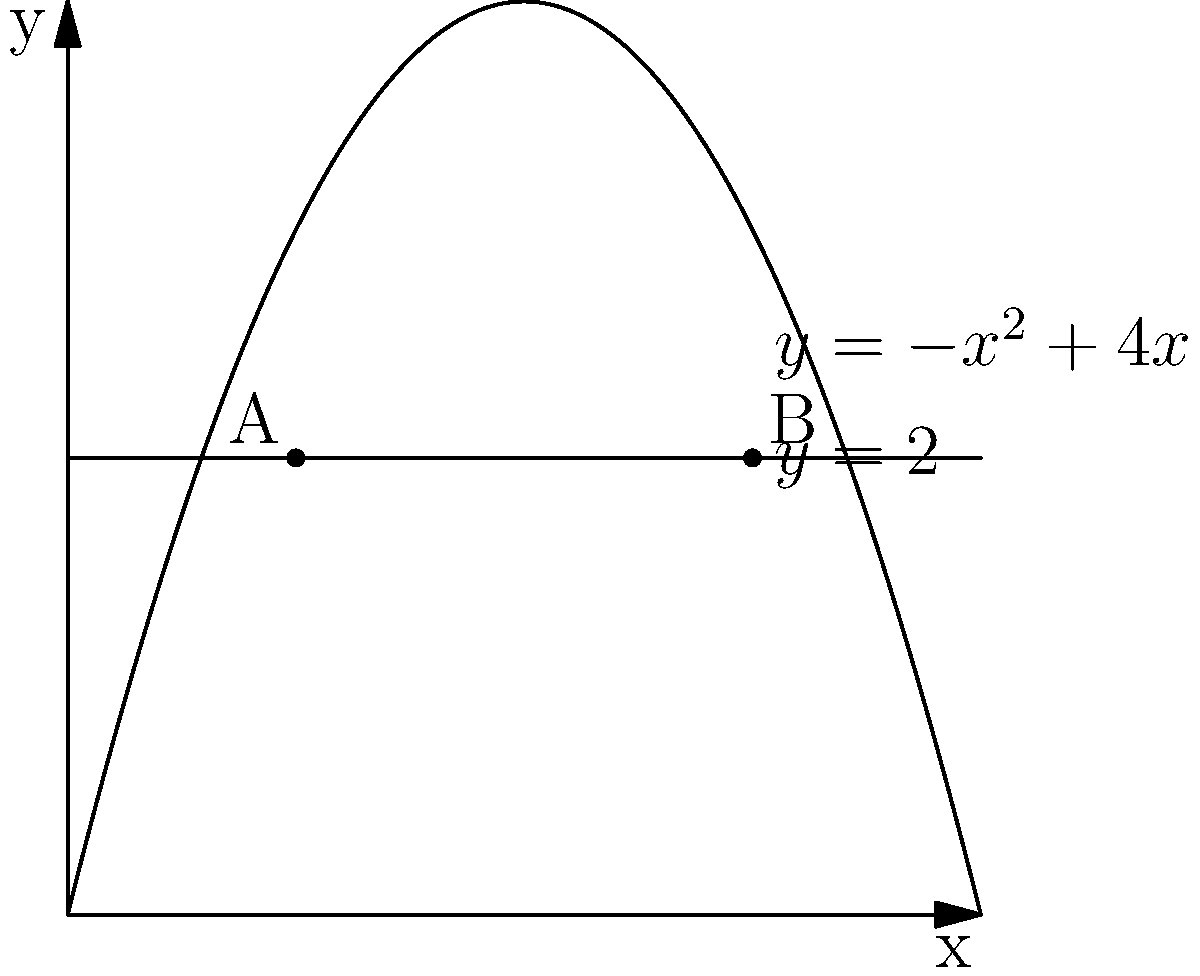A fantasy sports company wants to maximize its profit from a new mobile app. The profit function (in thousands of dollars) is given by $P(x) = -x^2 + 4x$, where $x$ represents the number of new features added to the app. However, due to budget constraints, the company can only afford to add a maximum of 2 new features. Use the method of Lagrange multipliers to determine the number of new features that should be added to maximize profit while satisfying the constraint. Let's approach this step-by-step using the method of Lagrange multipliers:

1) The objective function is $P(x) = -x^2 + 4x$
2) The constraint is $g(x) = x - 2 = 0$ (since x cannot exceed 2)

3) Form the Lagrangian function:
   $L(x,\lambda) = P(x) - \lambda g(x) = -x^2 + 4x - \lambda(x-2)$

4) Apply the necessary conditions:
   $\frac{\partial L}{\partial x} = -2x + 4 - \lambda = 0$ ... (1)
   $\frac{\partial L}{\partial \lambda} = -(x-2) = 0$ ... (2)

5) From (2), we get $x = 2$

6) Substitute this into (1):
   $-2(2) + 4 - \lambda = 0$
   $-4 + 4 - \lambda = 0$
   $\lambda = 0$

7) Since $\lambda = 0$, this point is a candidate for a local maximum.

8) To confirm, we need to check the endpoints of the constraint:
   At $x = 0$, $P(0) = 0$
   At $x = 2$, $P(2) = -4 + 8 = 4$

9) Therefore, the maximum profit occurs at $x = 2$

This solution aligns with the graph, where the constraint line $y = 2$ intersects the profit curve at its highest point within the feasible region.
Answer: 2 new features 